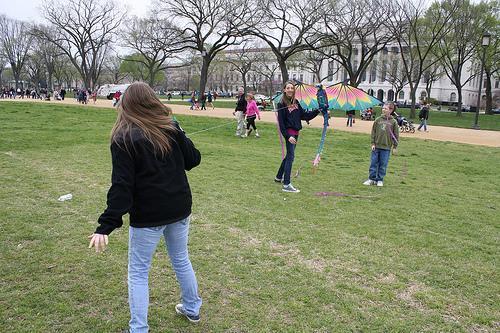How many people are wearing a pink jacket?
Give a very brief answer. 1. 